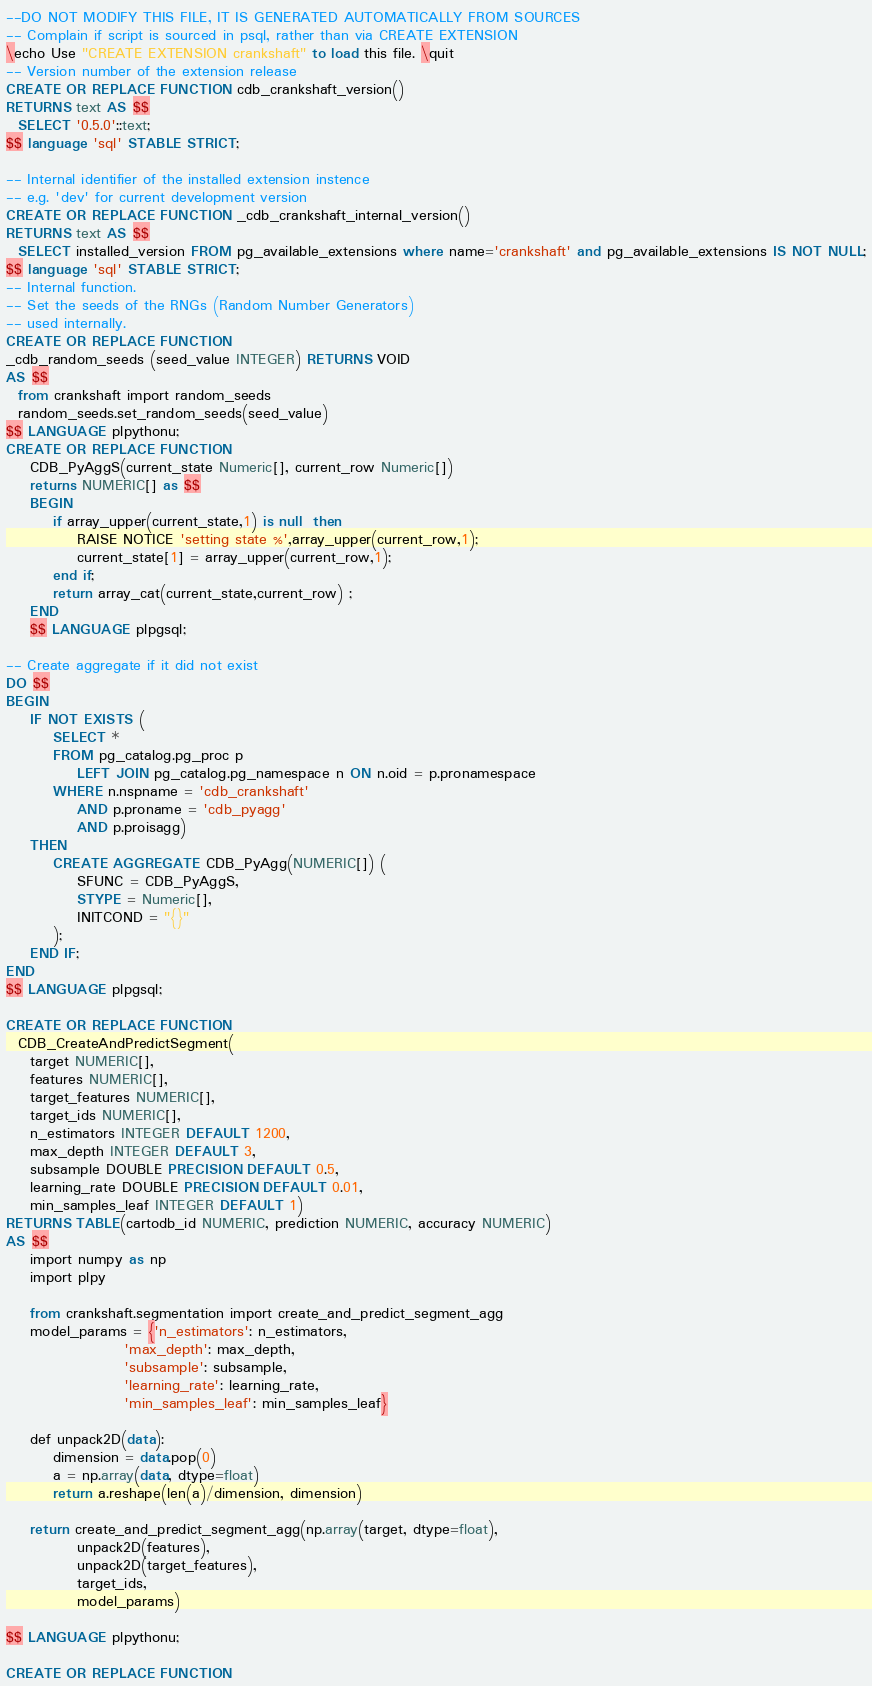<code> <loc_0><loc_0><loc_500><loc_500><_SQL_>--DO NOT MODIFY THIS FILE, IT IS GENERATED AUTOMATICALLY FROM SOURCES
-- Complain if script is sourced in psql, rather than via CREATE EXTENSION
\echo Use "CREATE EXTENSION crankshaft" to load this file. \quit
-- Version number of the extension release
CREATE OR REPLACE FUNCTION cdb_crankshaft_version()
RETURNS text AS $$
  SELECT '0.5.0'::text;
$$ language 'sql' STABLE STRICT;

-- Internal identifier of the installed extension instence
-- e.g. 'dev' for current development version
CREATE OR REPLACE FUNCTION _cdb_crankshaft_internal_version()
RETURNS text AS $$
  SELECT installed_version FROM pg_available_extensions where name='crankshaft' and pg_available_extensions IS NOT NULL;
$$ language 'sql' STABLE STRICT;
-- Internal function.
-- Set the seeds of the RNGs (Random Number Generators)
-- used internally.
CREATE OR REPLACE FUNCTION
_cdb_random_seeds (seed_value INTEGER) RETURNS VOID
AS $$
  from crankshaft import random_seeds
  random_seeds.set_random_seeds(seed_value)
$$ LANGUAGE plpythonu;
CREATE OR REPLACE FUNCTION
    CDB_PyAggS(current_state Numeric[], current_row Numeric[]) 
    returns NUMERIC[] as $$
    BEGIN
        if array_upper(current_state,1) is null  then
            RAISE NOTICE 'setting state %',array_upper(current_row,1);
            current_state[1] = array_upper(current_row,1);
        end if;
        return array_cat(current_state,current_row) ;
    END
    $$ LANGUAGE plpgsql;

-- Create aggregate if it did not exist
DO $$
BEGIN
    IF NOT EXISTS (
        SELECT *
        FROM pg_catalog.pg_proc p
            LEFT JOIN pg_catalog.pg_namespace n ON n.oid = p.pronamespace
        WHERE n.nspname = 'cdb_crankshaft'
            AND p.proname = 'cdb_pyagg'
            AND p.proisagg)
    THEN
        CREATE AGGREGATE CDB_PyAgg(NUMERIC[]) (
            SFUNC = CDB_PyAggS,
            STYPE = Numeric[],
            INITCOND = "{}"
        );
    END IF;
END
$$ LANGUAGE plpgsql;

CREATE OR REPLACE FUNCTION
  CDB_CreateAndPredictSegment(
    target NUMERIC[],
    features NUMERIC[],
    target_features NUMERIC[],
    target_ids NUMERIC[],
    n_estimators INTEGER DEFAULT 1200,
    max_depth INTEGER DEFAULT 3,
    subsample DOUBLE PRECISION DEFAULT 0.5,
    learning_rate DOUBLE PRECISION DEFAULT 0.01,
    min_samples_leaf INTEGER DEFAULT 1)
RETURNS TABLE(cartodb_id NUMERIC, prediction NUMERIC, accuracy NUMERIC)
AS $$
    import numpy as np
    import plpy

    from crankshaft.segmentation import create_and_predict_segment_agg
    model_params = {'n_estimators': n_estimators,
                    'max_depth': max_depth,
                    'subsample': subsample,
                    'learning_rate': learning_rate,
                    'min_samples_leaf': min_samples_leaf}

    def unpack2D(data):
        dimension = data.pop(0)
        a = np.array(data, dtype=float)
        return a.reshape(len(a)/dimension, dimension)

    return create_and_predict_segment_agg(np.array(target, dtype=float),
            unpack2D(features),
            unpack2D(target_features),
            target_ids,
            model_params)

$$ LANGUAGE plpythonu;

CREATE OR REPLACE FUNCTION</code> 